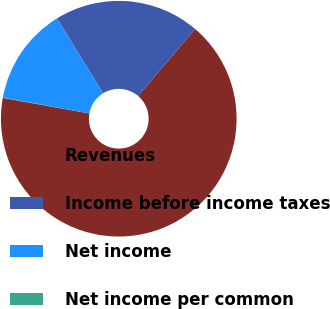Convert chart to OTSL. <chart><loc_0><loc_0><loc_500><loc_500><pie_chart><fcel>Revenues<fcel>Income before income taxes<fcel>Net income<fcel>Net income per common<nl><fcel>66.6%<fcel>20.01%<fcel>13.35%<fcel>0.04%<nl></chart> 